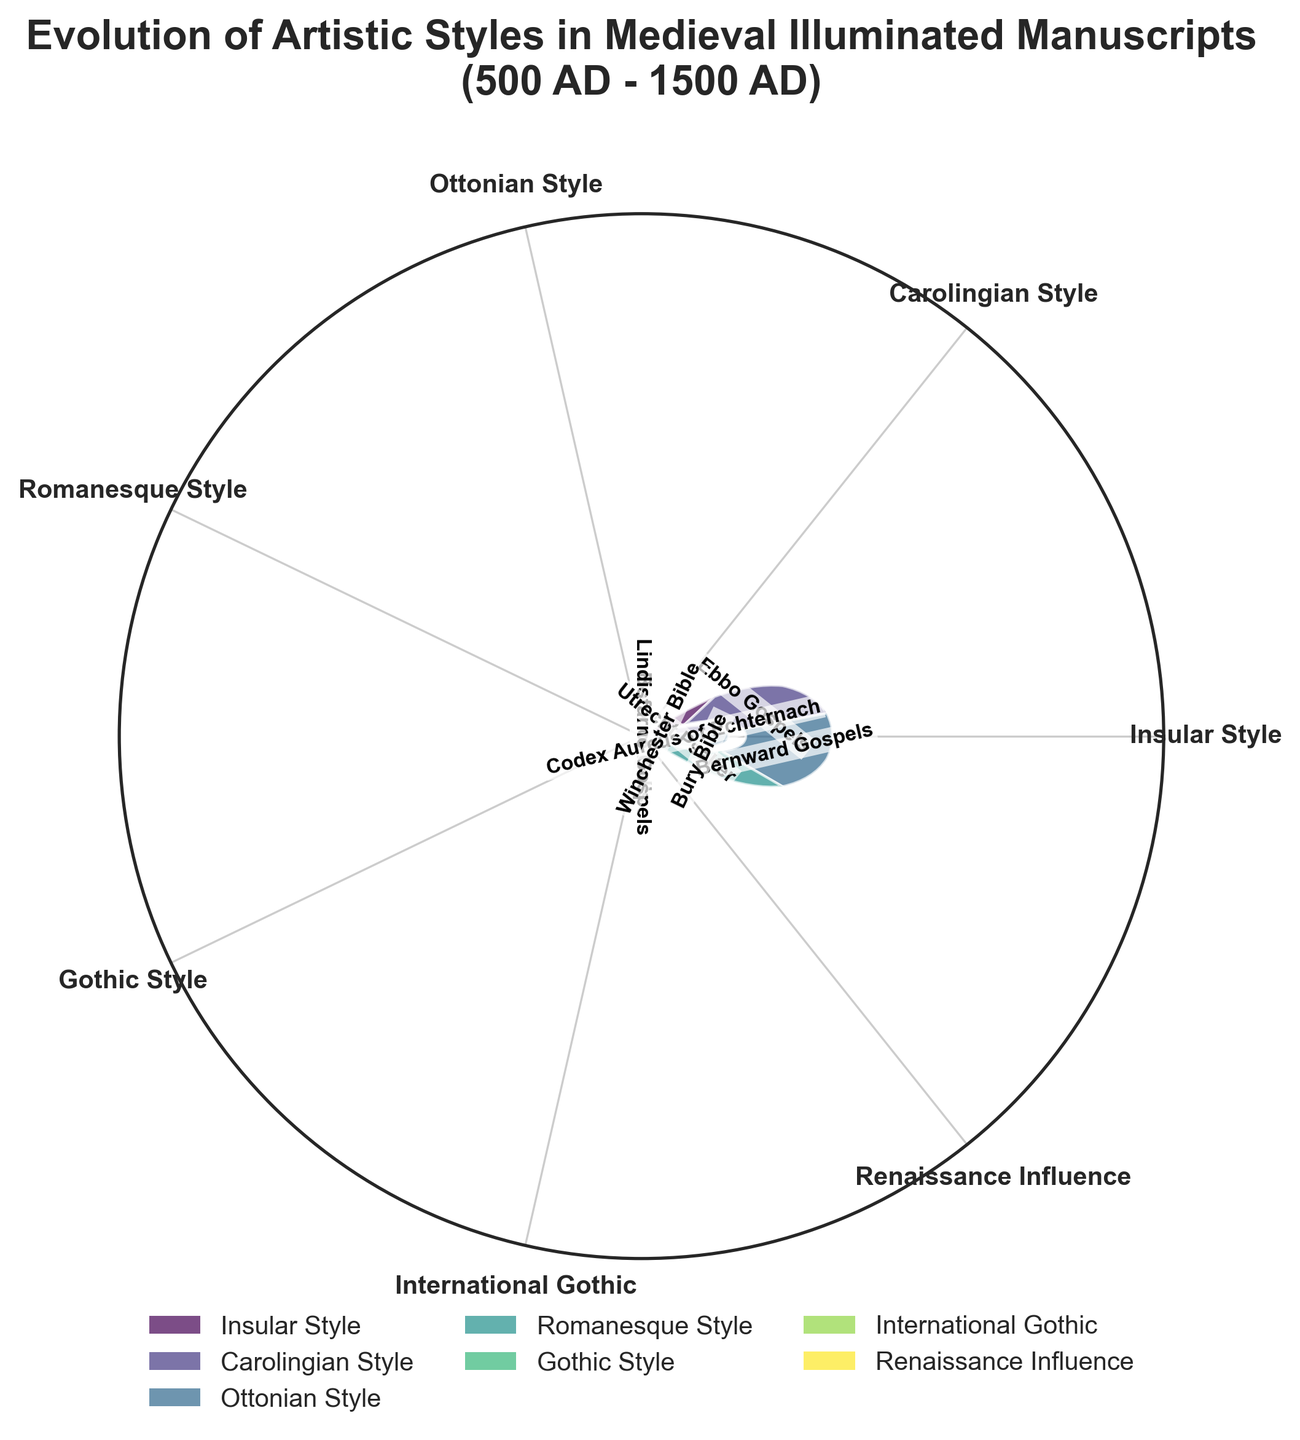What is the title of the plot? The title is located at the top of the plot and reads "Evolution of Artistic Styles in Medieval Illuminated Manuscripts (500 AD - 1500 AD)"
Answer: Evolution of Artistic Styles in Medieval Illuminated Manuscripts (500 AD - 1500 AD) Which artistic style has the highest value represented in the chart? We need to identify the wedge with the highest value by looking at each artistic style. The Gothic Style's "Très Riches Heures du Duc de Berry" has the highest value of 40.
Answer: Gothic Style How many subcategories are there in the Carolingian Style? By examining the Carolingian Style section, we see there are two wedges: "Utrecht Psalter" and "Ebbo Gospels."
Answer: 2 What is the range of values within the Insular Style? The Insular Style has two values, 25 and 20. The range is the difference between the highest and lowest values, which is 25 - 20 = 5.
Answer: 5 How does the value of the Hours of Catherine of Cleves in Gothic Style compare to the value of the Bury Bible in Romanesque Style? Compare the values visually from the chart. The Hours of Catherine of Cleves has a value of 35 and the Bury Bible has a value of 30. The difference is 35 - 30 = 5.
Answer: 5 What is the difference between the maximum value in Gothic Style and the minimum value in International Gothic? The maximum value in Gothic Style is 40 ("Très Riches Heures du Duc de Berry") and the minimum value in International Gothic is 20 ("Limbourg Brothers' Works"). The difference is 40 - 20 = 20.
Answer: 20 